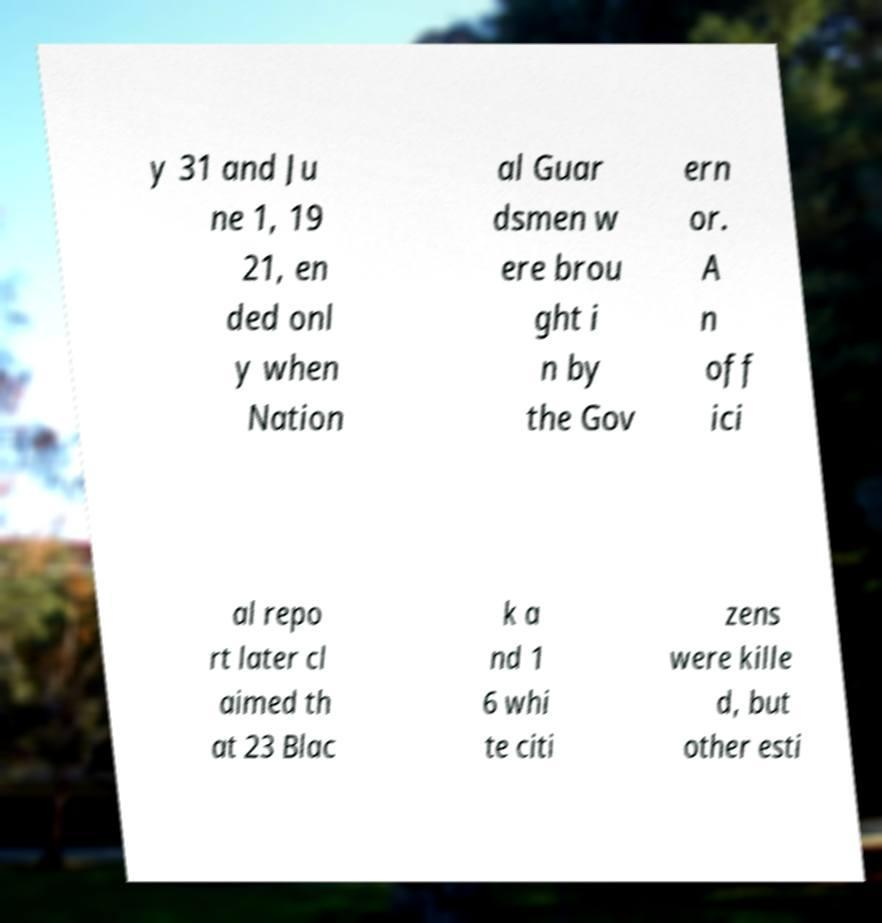Please identify and transcribe the text found in this image. y 31 and Ju ne 1, 19 21, en ded onl y when Nation al Guar dsmen w ere brou ght i n by the Gov ern or. A n off ici al repo rt later cl aimed th at 23 Blac k a nd 1 6 whi te citi zens were kille d, but other esti 